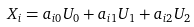Convert formula to latex. <formula><loc_0><loc_0><loc_500><loc_500>X _ { i } = a _ { i 0 } U _ { 0 } + a _ { i 1 } U _ { 1 } + a _ { i 2 } U _ { 2 }</formula> 